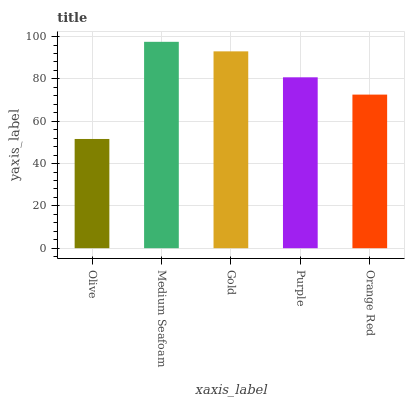Is Olive the minimum?
Answer yes or no. Yes. Is Medium Seafoam the maximum?
Answer yes or no. Yes. Is Gold the minimum?
Answer yes or no. No. Is Gold the maximum?
Answer yes or no. No. Is Medium Seafoam greater than Gold?
Answer yes or no. Yes. Is Gold less than Medium Seafoam?
Answer yes or no. Yes. Is Gold greater than Medium Seafoam?
Answer yes or no. No. Is Medium Seafoam less than Gold?
Answer yes or no. No. Is Purple the high median?
Answer yes or no. Yes. Is Purple the low median?
Answer yes or no. Yes. Is Gold the high median?
Answer yes or no. No. Is Orange Red the low median?
Answer yes or no. No. 